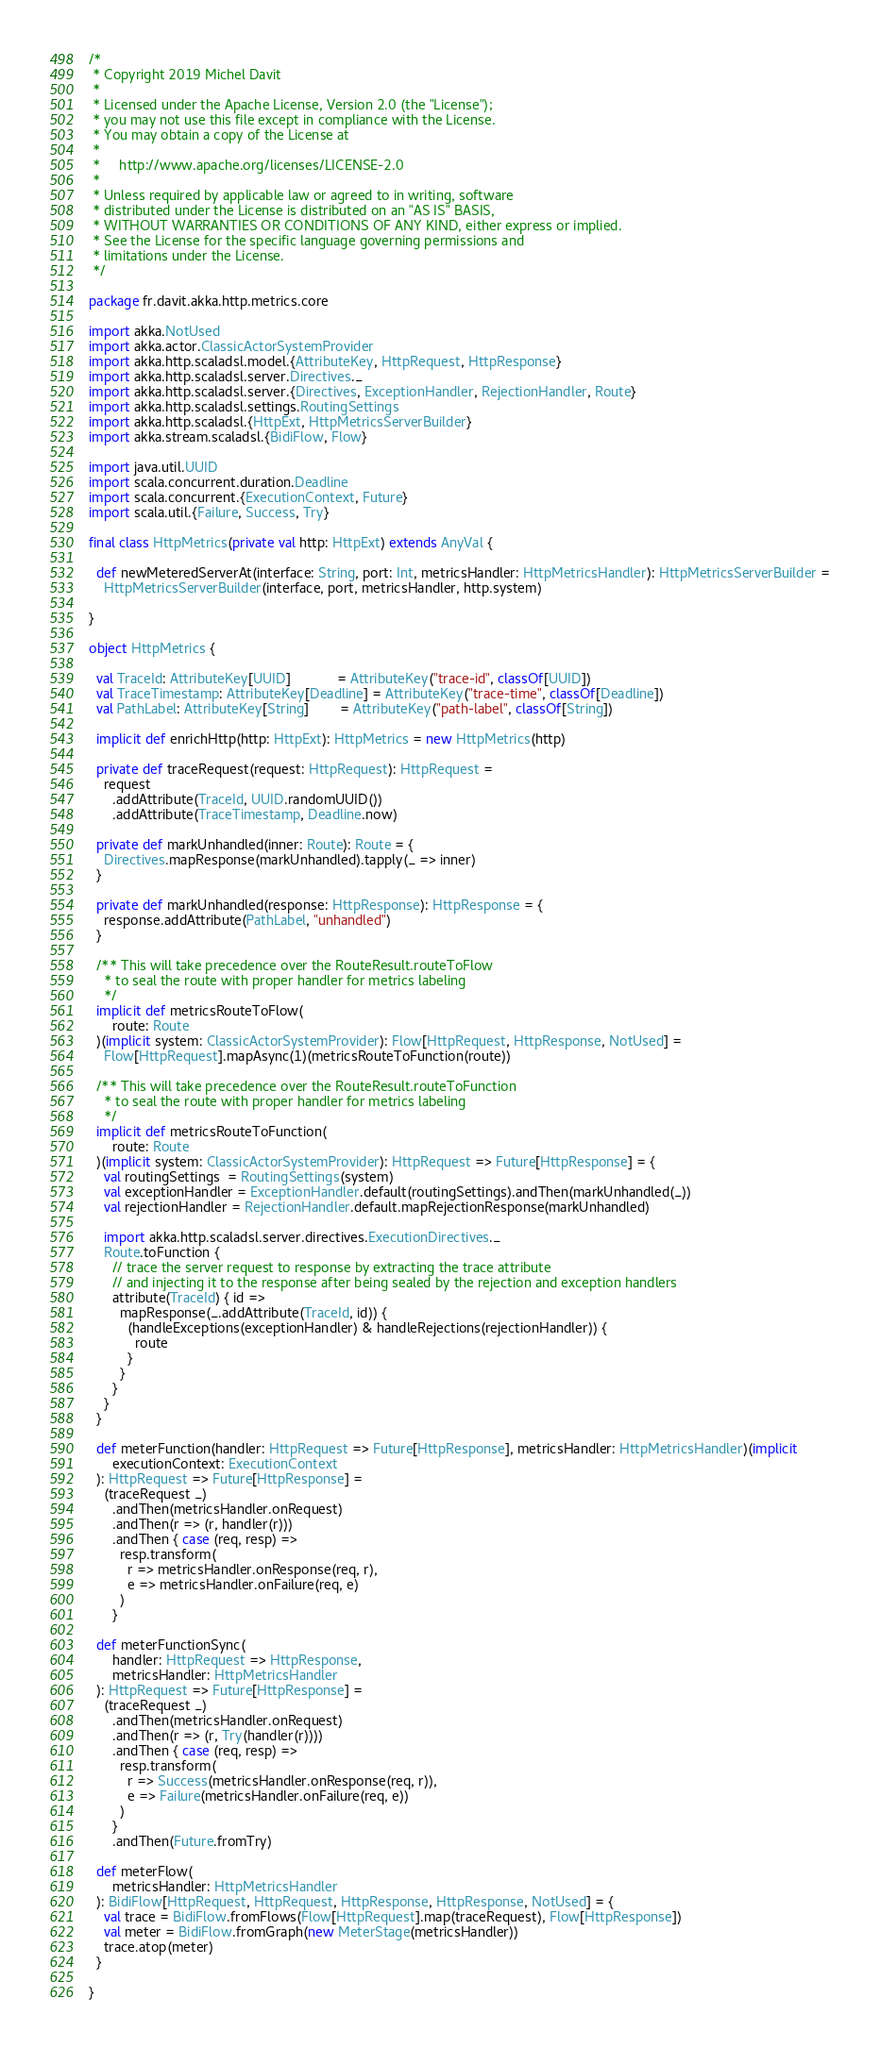<code> <loc_0><loc_0><loc_500><loc_500><_Scala_>/*
 * Copyright 2019 Michel Davit
 *
 * Licensed under the Apache License, Version 2.0 (the "License");
 * you may not use this file except in compliance with the License.
 * You may obtain a copy of the License at
 *
 *     http://www.apache.org/licenses/LICENSE-2.0
 *
 * Unless required by applicable law or agreed to in writing, software
 * distributed under the License is distributed on an "AS IS" BASIS,
 * WITHOUT WARRANTIES OR CONDITIONS OF ANY KIND, either express or implied.
 * See the License for the specific language governing permissions and
 * limitations under the License.
 */

package fr.davit.akka.http.metrics.core

import akka.NotUsed
import akka.actor.ClassicActorSystemProvider
import akka.http.scaladsl.model.{AttributeKey, HttpRequest, HttpResponse}
import akka.http.scaladsl.server.Directives._
import akka.http.scaladsl.server.{Directives, ExceptionHandler, RejectionHandler, Route}
import akka.http.scaladsl.settings.RoutingSettings
import akka.http.scaladsl.{HttpExt, HttpMetricsServerBuilder}
import akka.stream.scaladsl.{BidiFlow, Flow}

import java.util.UUID
import scala.concurrent.duration.Deadline
import scala.concurrent.{ExecutionContext, Future}
import scala.util.{Failure, Success, Try}

final class HttpMetrics(private val http: HttpExt) extends AnyVal {

  def newMeteredServerAt(interface: String, port: Int, metricsHandler: HttpMetricsHandler): HttpMetricsServerBuilder =
    HttpMetricsServerBuilder(interface, port, metricsHandler, http.system)

}

object HttpMetrics {

  val TraceId: AttributeKey[UUID]            = AttributeKey("trace-id", classOf[UUID])
  val TraceTimestamp: AttributeKey[Deadline] = AttributeKey("trace-time", classOf[Deadline])
  val PathLabel: AttributeKey[String]        = AttributeKey("path-label", classOf[String])

  implicit def enrichHttp(http: HttpExt): HttpMetrics = new HttpMetrics(http)

  private def traceRequest(request: HttpRequest): HttpRequest =
    request
      .addAttribute(TraceId, UUID.randomUUID())
      .addAttribute(TraceTimestamp, Deadline.now)

  private def markUnhandled(inner: Route): Route = {
    Directives.mapResponse(markUnhandled).tapply(_ => inner)
  }

  private def markUnhandled(response: HttpResponse): HttpResponse = {
    response.addAttribute(PathLabel, "unhandled")
  }

  /** This will take precedence over the RouteResult.routeToFlow
    * to seal the route with proper handler for metrics labeling
    */
  implicit def metricsRouteToFlow(
      route: Route
  )(implicit system: ClassicActorSystemProvider): Flow[HttpRequest, HttpResponse, NotUsed] =
    Flow[HttpRequest].mapAsync(1)(metricsRouteToFunction(route))

  /** This will take precedence over the RouteResult.routeToFunction
    * to seal the route with proper handler for metrics labeling
    */
  implicit def metricsRouteToFunction(
      route: Route
  )(implicit system: ClassicActorSystemProvider): HttpRequest => Future[HttpResponse] = {
    val routingSettings  = RoutingSettings(system)
    val exceptionHandler = ExceptionHandler.default(routingSettings).andThen(markUnhandled(_))
    val rejectionHandler = RejectionHandler.default.mapRejectionResponse(markUnhandled)

    import akka.http.scaladsl.server.directives.ExecutionDirectives._
    Route.toFunction {
      // trace the server request to response by extracting the trace attribute
      // and injecting it to the response after being sealed by the rejection and exception handlers
      attribute(TraceId) { id =>
        mapResponse(_.addAttribute(TraceId, id)) {
          (handleExceptions(exceptionHandler) & handleRejections(rejectionHandler)) {
            route
          }
        }
      }
    }
  }

  def meterFunction(handler: HttpRequest => Future[HttpResponse], metricsHandler: HttpMetricsHandler)(implicit
      executionContext: ExecutionContext
  ): HttpRequest => Future[HttpResponse] =
    (traceRequest _)
      .andThen(metricsHandler.onRequest)
      .andThen(r => (r, handler(r)))
      .andThen { case (req, resp) =>
        resp.transform(
          r => metricsHandler.onResponse(req, r),
          e => metricsHandler.onFailure(req, e)
        )
      }

  def meterFunctionSync(
      handler: HttpRequest => HttpResponse,
      metricsHandler: HttpMetricsHandler
  ): HttpRequest => Future[HttpResponse] =
    (traceRequest _)
      .andThen(metricsHandler.onRequest)
      .andThen(r => (r, Try(handler(r))))
      .andThen { case (req, resp) =>
        resp.transform(
          r => Success(metricsHandler.onResponse(req, r)),
          e => Failure(metricsHandler.onFailure(req, e))
        )
      }
      .andThen(Future.fromTry)

  def meterFlow(
      metricsHandler: HttpMetricsHandler
  ): BidiFlow[HttpRequest, HttpRequest, HttpResponse, HttpResponse, NotUsed] = {
    val trace = BidiFlow.fromFlows(Flow[HttpRequest].map(traceRequest), Flow[HttpResponse])
    val meter = BidiFlow.fromGraph(new MeterStage(metricsHandler))
    trace.atop(meter)
  }

}
</code> 